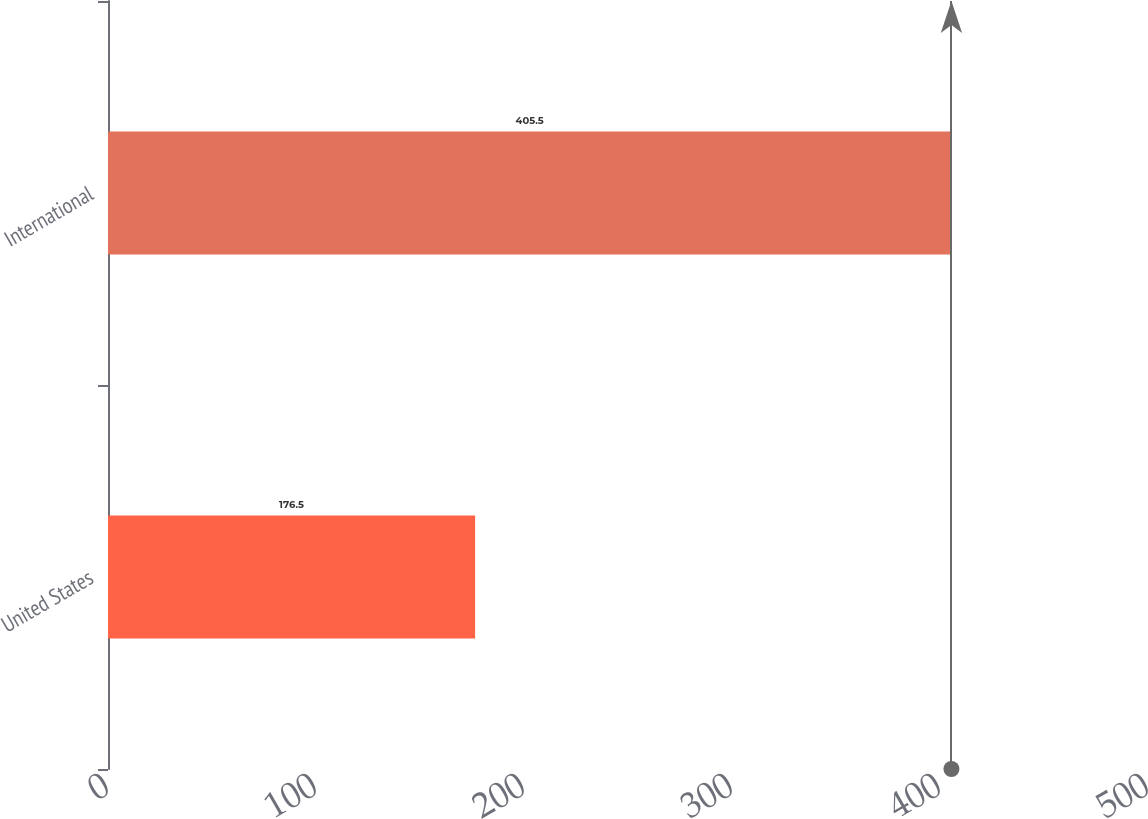Convert chart to OTSL. <chart><loc_0><loc_0><loc_500><loc_500><bar_chart><fcel>United States<fcel>International<nl><fcel>176.5<fcel>405.5<nl></chart> 